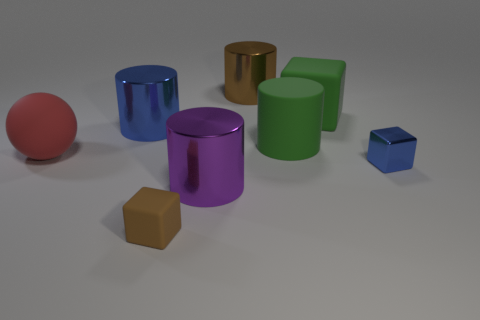There is a large thing that is the same color as the metallic block; what is it made of?
Your answer should be very brief. Metal. Do the brown metal cylinder and the metal cube have the same size?
Provide a succinct answer. No. How many objects are either purple shiny objects or big green matte cylinders?
Keep it short and to the point. 2. What size is the blue metallic thing right of the small block on the left side of the purple thing?
Keep it short and to the point. Small. What size is the brown rubber cube?
Make the answer very short. Small. What shape is the thing that is to the right of the brown cylinder and in front of the red matte ball?
Provide a succinct answer. Cube. There is another tiny object that is the same shape as the small shiny object; what color is it?
Provide a succinct answer. Brown. What number of objects are large cylinders that are behind the large green cylinder or metal things that are left of the tiny brown matte thing?
Provide a succinct answer. 2. What is the shape of the tiny brown rubber object?
Your answer should be very brief. Cube. There is a large rubber thing that is the same color as the large matte cylinder; what shape is it?
Ensure brevity in your answer.  Cube. 